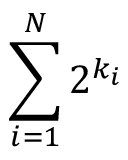<formula> <loc_0><loc_0><loc_500><loc_500>\sum _ { i = 1 } ^ { N } 2 ^ { k _ { i } }</formula> 